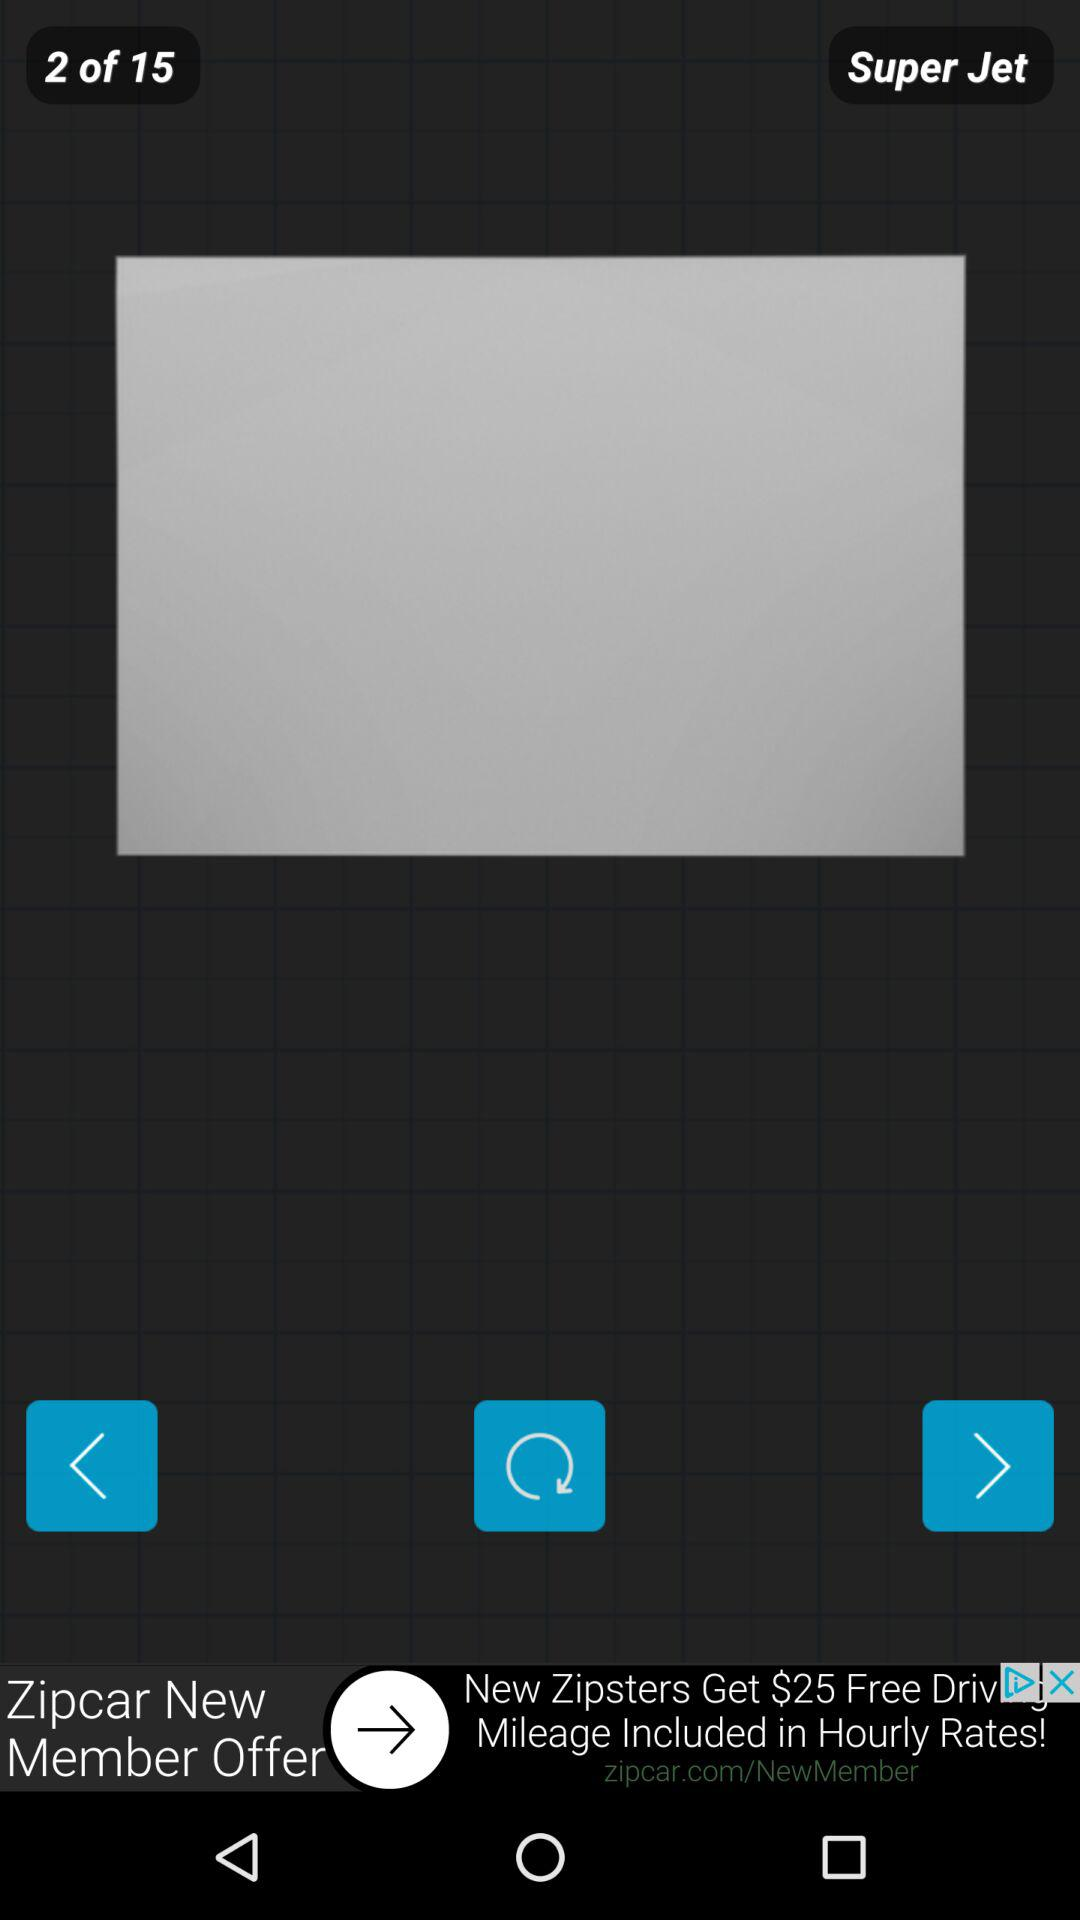What is the user's name?
When the provided information is insufficient, respond with <no answer>. <no answer> 